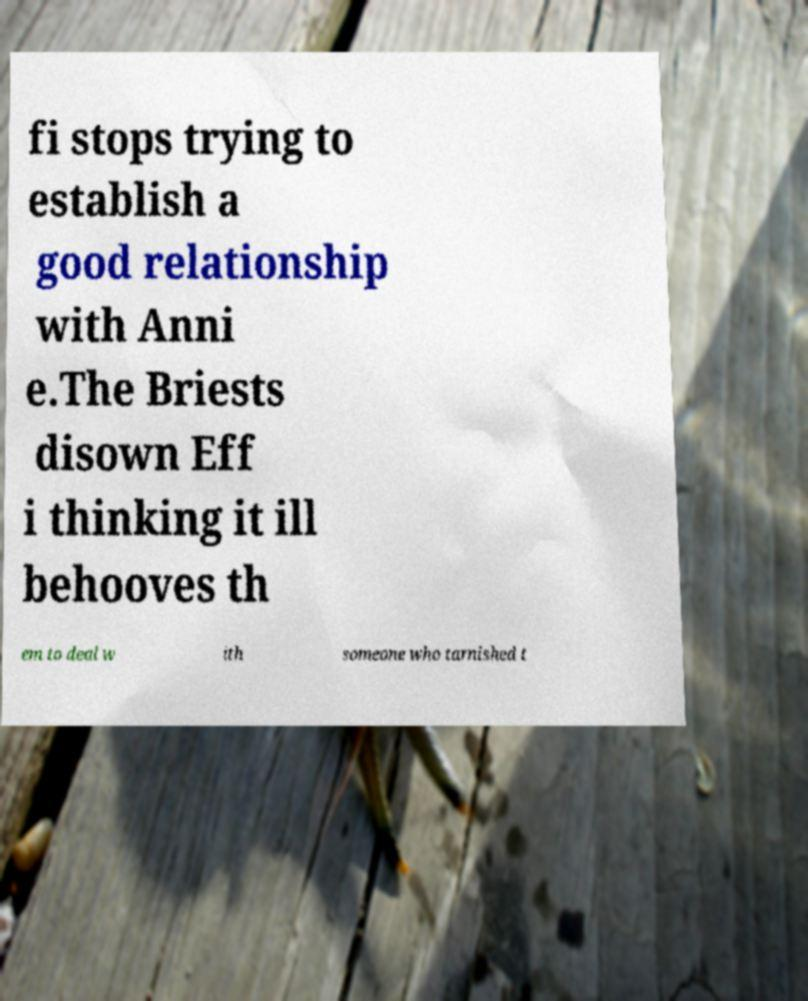Could you extract and type out the text from this image? fi stops trying to establish a good relationship with Anni e.The Briests disown Eff i thinking it ill behooves th em to deal w ith someone who tarnished t 